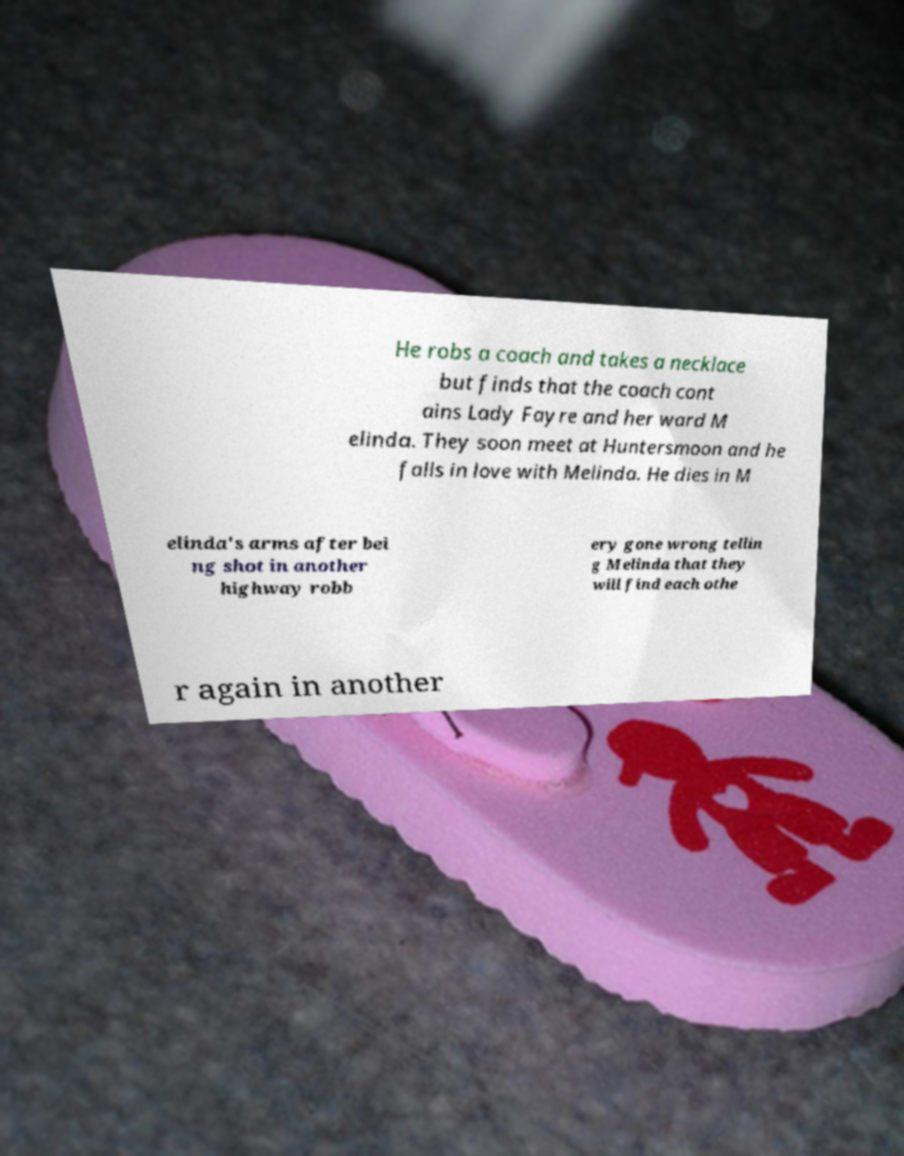Can you read and provide the text displayed in the image?This photo seems to have some interesting text. Can you extract and type it out for me? He robs a coach and takes a necklace but finds that the coach cont ains Lady Fayre and her ward M elinda. They soon meet at Huntersmoon and he falls in love with Melinda. He dies in M elinda's arms after bei ng shot in another highway robb ery gone wrong tellin g Melinda that they will find each othe r again in another 